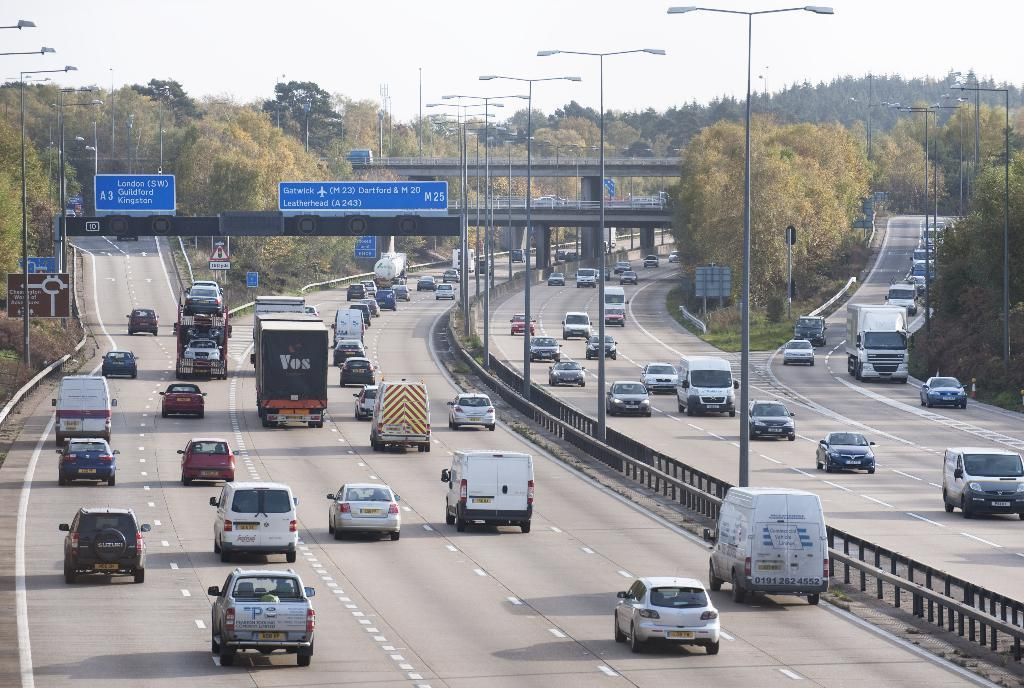What can be seen in the sky in the image? The sky is visible in the image. What type of natural elements are present in the image? There are trees in the image. What type of structure is present in the image? There is a bridge in the image. What type of transportation is present in the image? Vehicles are present on the road in the image. What type of illumination is visible in the image? Lights are visible in the image. What type of vertical structures are present in the image? Poles are present in the image. What type of signage is present in the image? Blue color boards and other boards are in the image. What type of barrier is present in the middle of the road? There is a railing in the middle of the road. What type of lace is draped over the trees in the image? There is no lace present in the image; it features a sky, trees, bridge, vehicles, lights, poles, signage, and a railing. What type of event is taking place in the image? There is no indication of an event taking place in the image. 